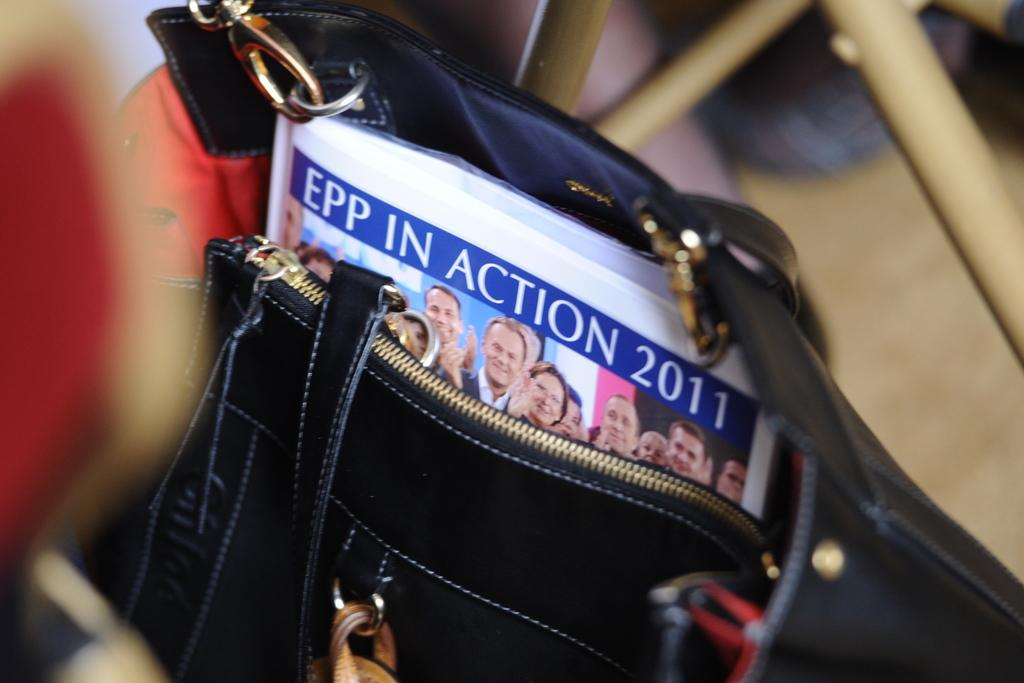What object is visible in the image? There is a bag in the image. What color is the bag? The bag is black in color. What is inside the bag? There is a book inside the bag. How does the skirt move in the image? There is no skirt present in the image. What type of foot is visible in the image? There are no feet visible in the image. 